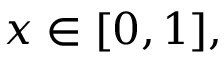<formula> <loc_0><loc_0><loc_500><loc_500>x \in [ 0 , 1 ] ,</formula> 